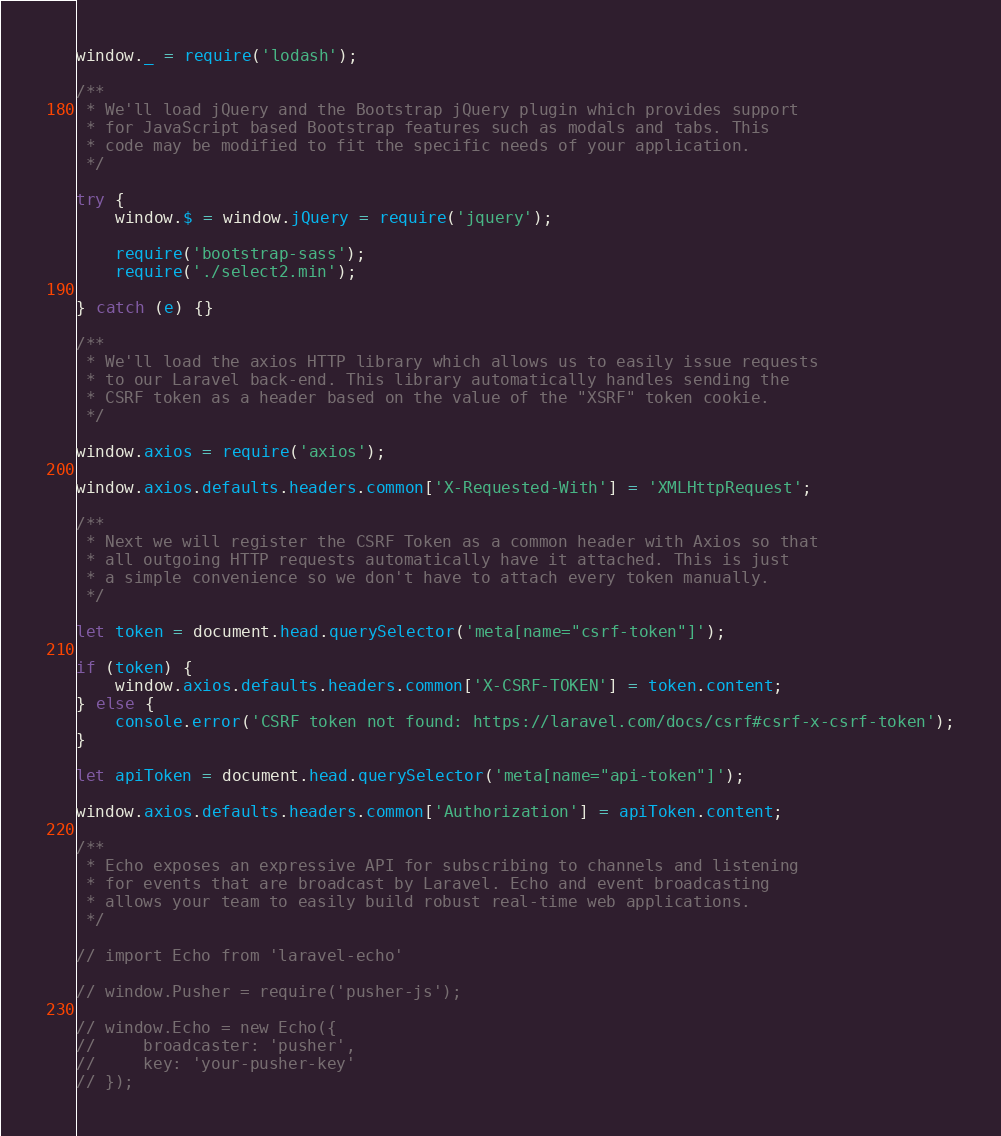Convert code to text. <code><loc_0><loc_0><loc_500><loc_500><_JavaScript_>
window._ = require('lodash');

/**
 * We'll load jQuery and the Bootstrap jQuery plugin which provides support
 * for JavaScript based Bootstrap features such as modals and tabs. This
 * code may be modified to fit the specific needs of your application.
 */

try {
    window.$ = window.jQuery = require('jquery');

    require('bootstrap-sass');
    require('./select2.min');

} catch (e) {}

/**
 * We'll load the axios HTTP library which allows us to easily issue requests
 * to our Laravel back-end. This library automatically handles sending the
 * CSRF token as a header based on the value of the "XSRF" token cookie.
 */

window.axios = require('axios');

window.axios.defaults.headers.common['X-Requested-With'] = 'XMLHttpRequest';

/**
 * Next we will register the CSRF Token as a common header with Axios so that
 * all outgoing HTTP requests automatically have it attached. This is just
 * a simple convenience so we don't have to attach every token manually.
 */

let token = document.head.querySelector('meta[name="csrf-token"]');

if (token) {
    window.axios.defaults.headers.common['X-CSRF-TOKEN'] = token.content;
} else {
    console.error('CSRF token not found: https://laravel.com/docs/csrf#csrf-x-csrf-token');
}

let apiToken = document.head.querySelector('meta[name="api-token"]');

window.axios.defaults.headers.common['Authorization'] = apiToken.content;

/**
 * Echo exposes an expressive API for subscribing to channels and listening
 * for events that are broadcast by Laravel. Echo and event broadcasting
 * allows your team to easily build robust real-time web applications.
 */

// import Echo from 'laravel-echo'

// window.Pusher = require('pusher-js');

// window.Echo = new Echo({
//     broadcaster: 'pusher',
//     key: 'your-pusher-key'
// });
</code> 